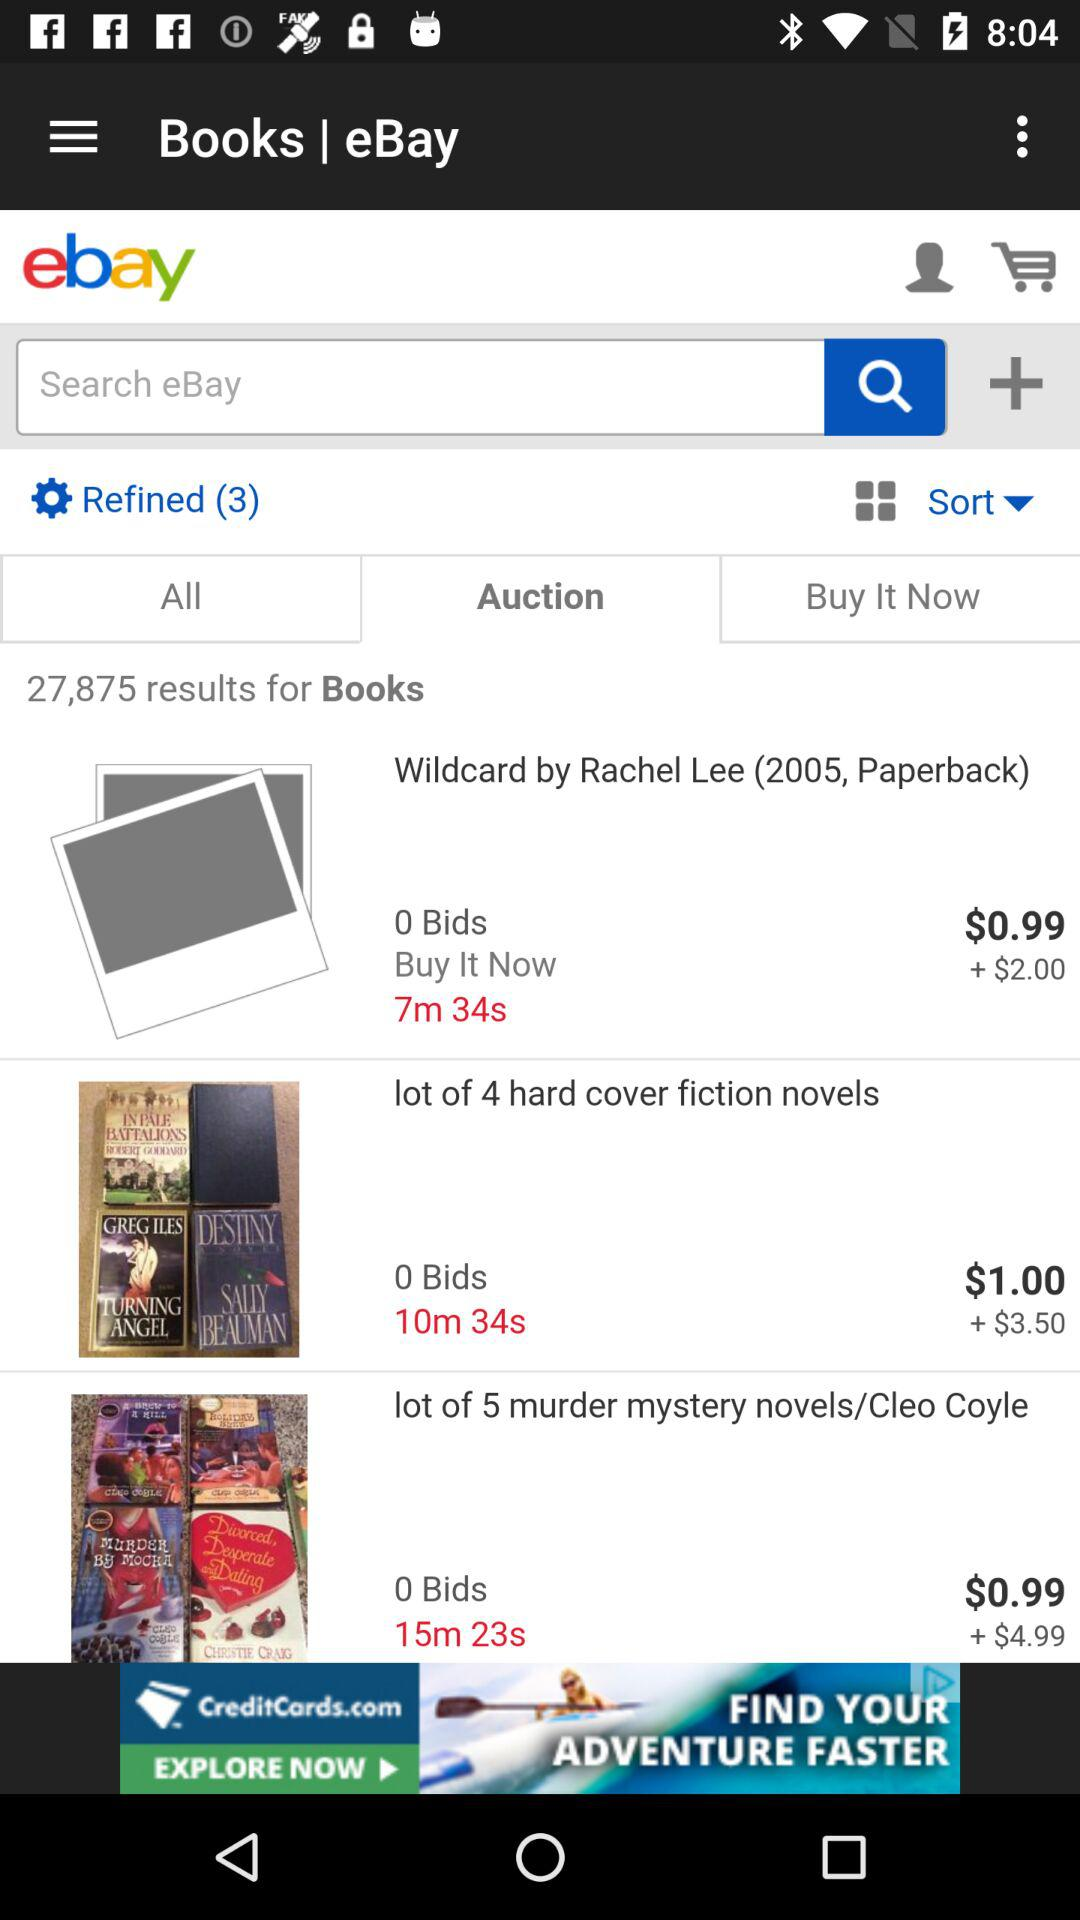What is the application name? The application name is "eBay". 